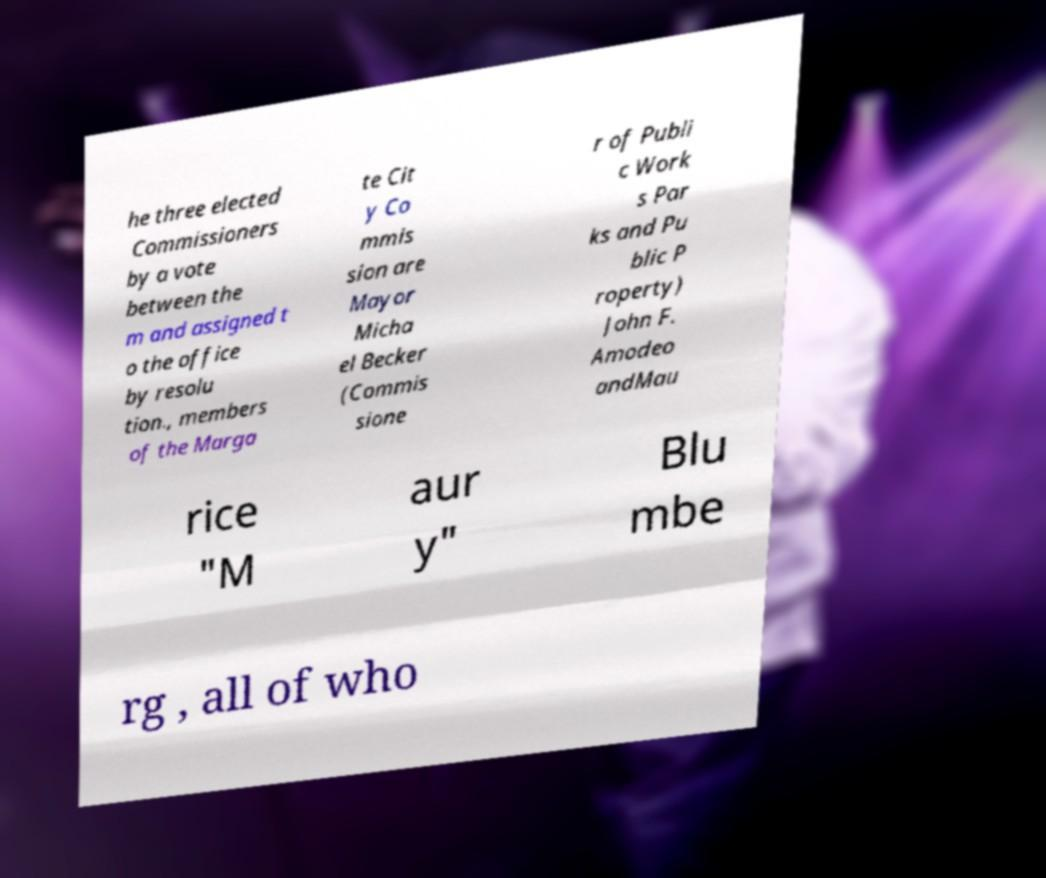Please read and relay the text visible in this image. What does it say? he three elected Commissioners by a vote between the m and assigned t o the office by resolu tion., members of the Marga te Cit y Co mmis sion are Mayor Micha el Becker (Commis sione r of Publi c Work s Par ks and Pu blic P roperty) John F. Amodeo andMau rice "M aur y" Blu mbe rg , all of who 